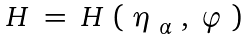Convert formula to latex. <formula><loc_0><loc_0><loc_500><loc_500>\begin{array} { l } H \ = \ H \ ( \ \eta _ { \ \alpha } \ , \ \varphi \ ) \end{array}</formula> 